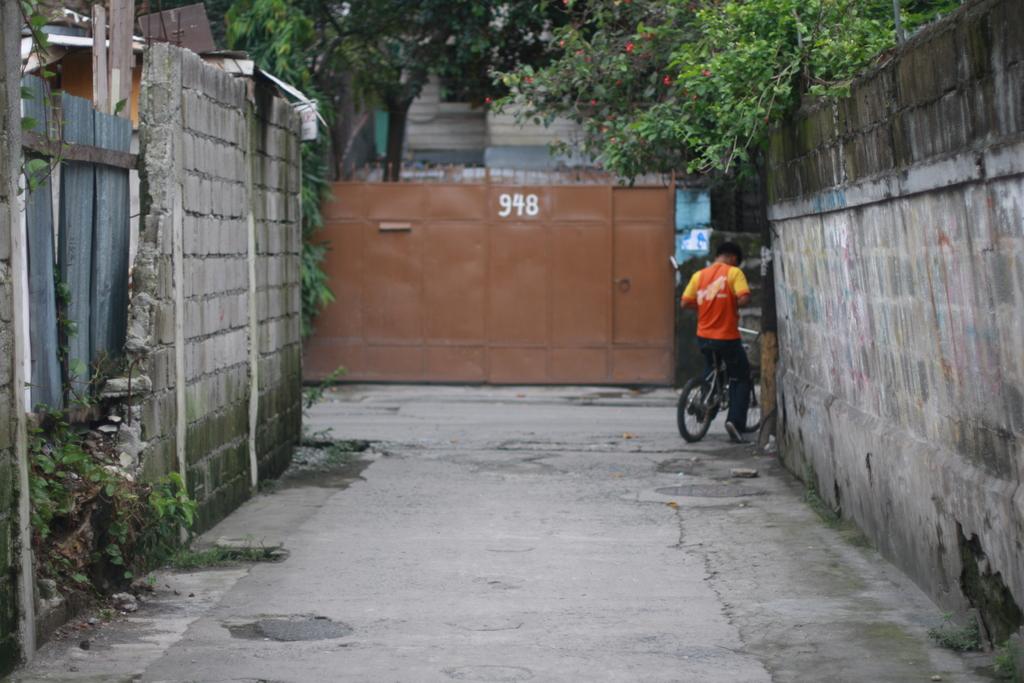What is the address?
Make the answer very short. 948. 